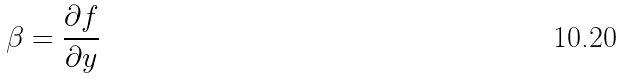<formula> <loc_0><loc_0><loc_500><loc_500>\beta = \frac { \partial f } { \partial y }</formula> 